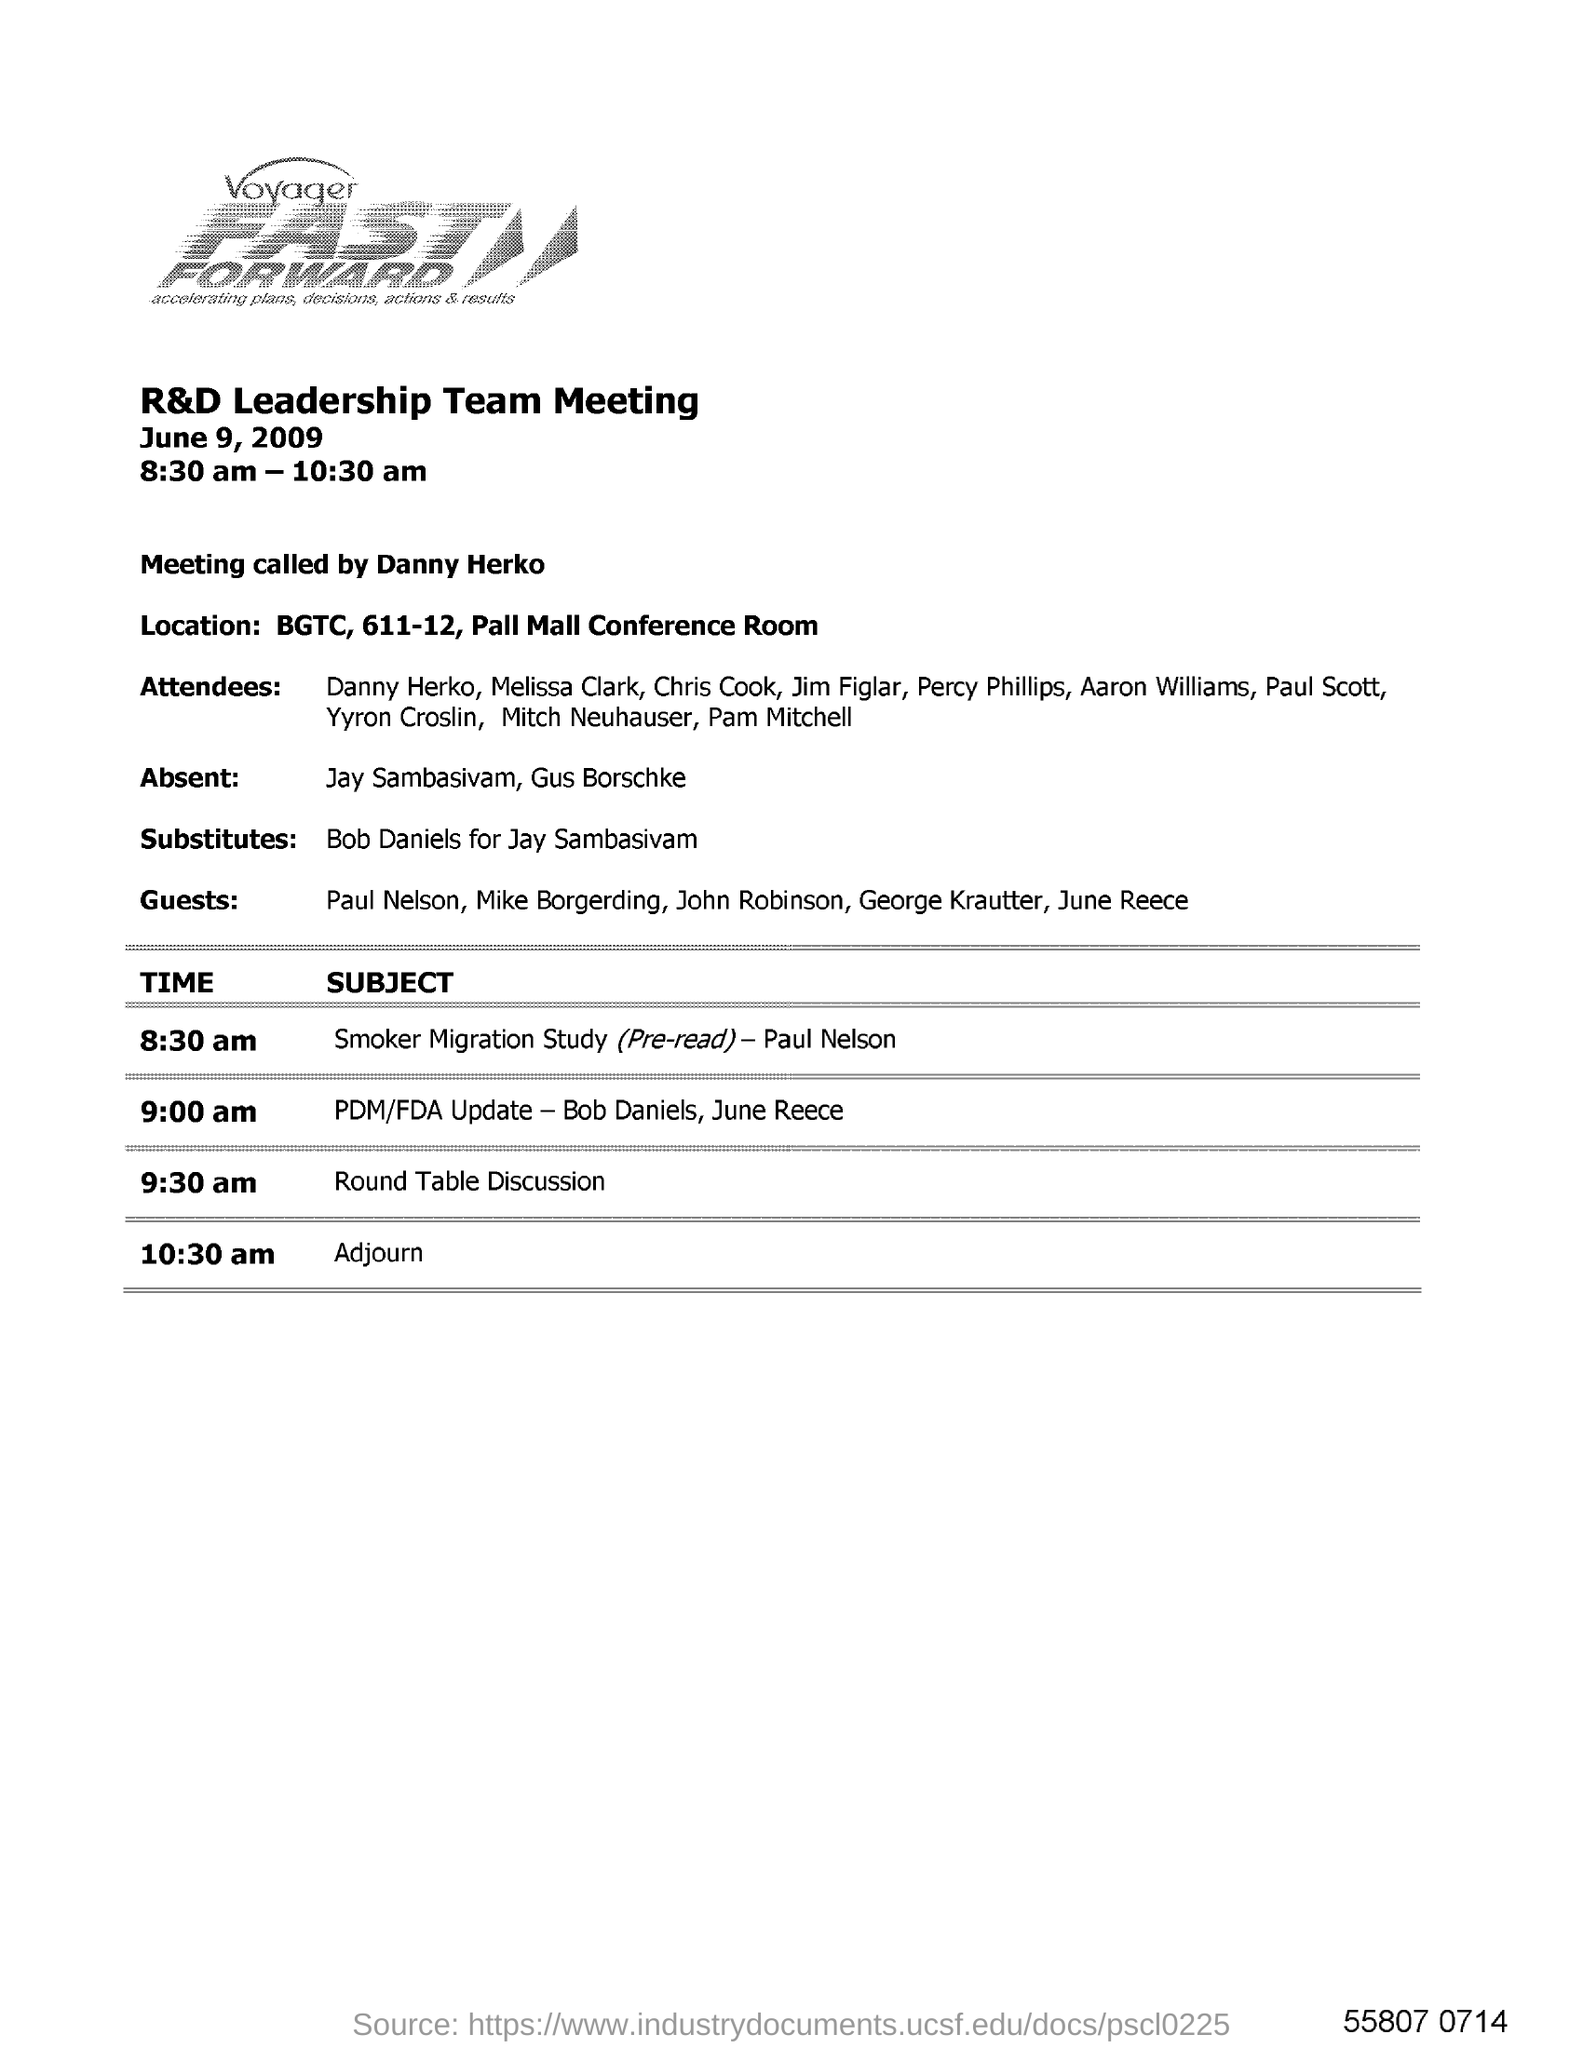What was the time of R&d Leadership team meeting?
Ensure brevity in your answer.  8:30 am - 10:30 am. Who called the meeting?
Make the answer very short. Danny herko. What was location of the meeting?
Offer a very short reply. BGTC, 611-12, Pall mall conference room. Who were absent for the meeting?
Make the answer very short. Jay Sambasivam, Gus Borschke. What was the time for the round table discussion?
Give a very brief answer. 9:30 am. What is the fast forward tagline?
Offer a very short reply. Accelerating plans, decisions, actions & results. 